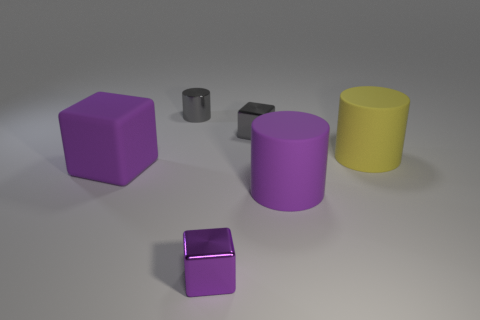Add 2 large yellow matte cylinders. How many objects exist? 8 Subtract all tiny brown rubber cylinders. Subtract all big yellow rubber cylinders. How many objects are left? 5 Add 4 big yellow matte cylinders. How many big yellow matte cylinders are left? 5 Add 3 large things. How many large things exist? 6 Subtract 0 blue cylinders. How many objects are left? 6 